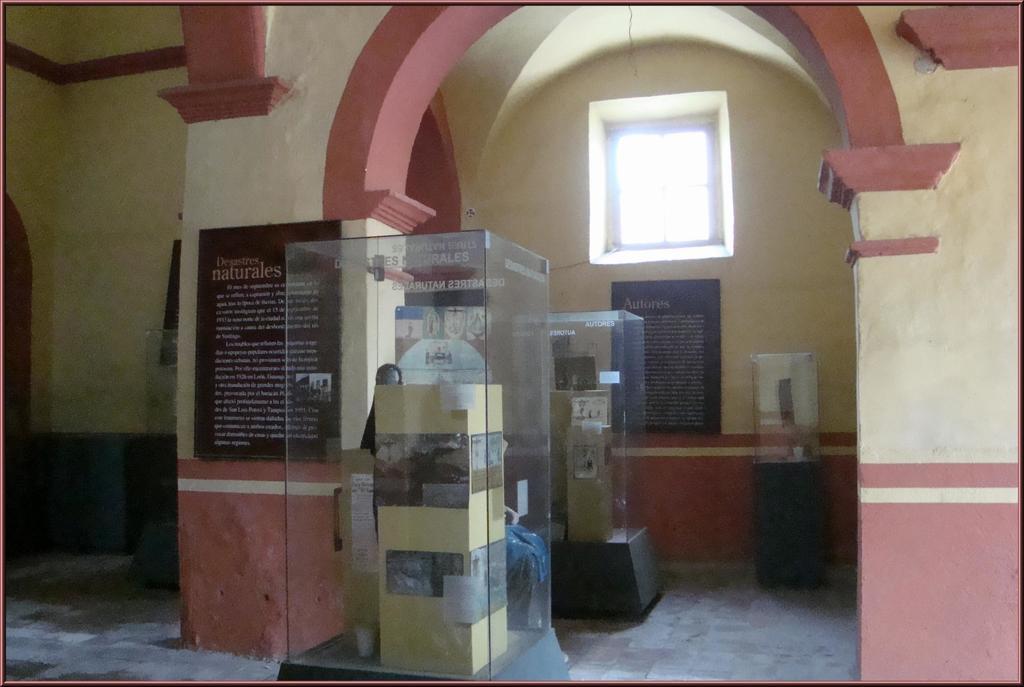Please provide a concise description of this image. In this image there are a few posts attached to the small pillar inside the glass objects, there are posters attached to the wall and a window. 